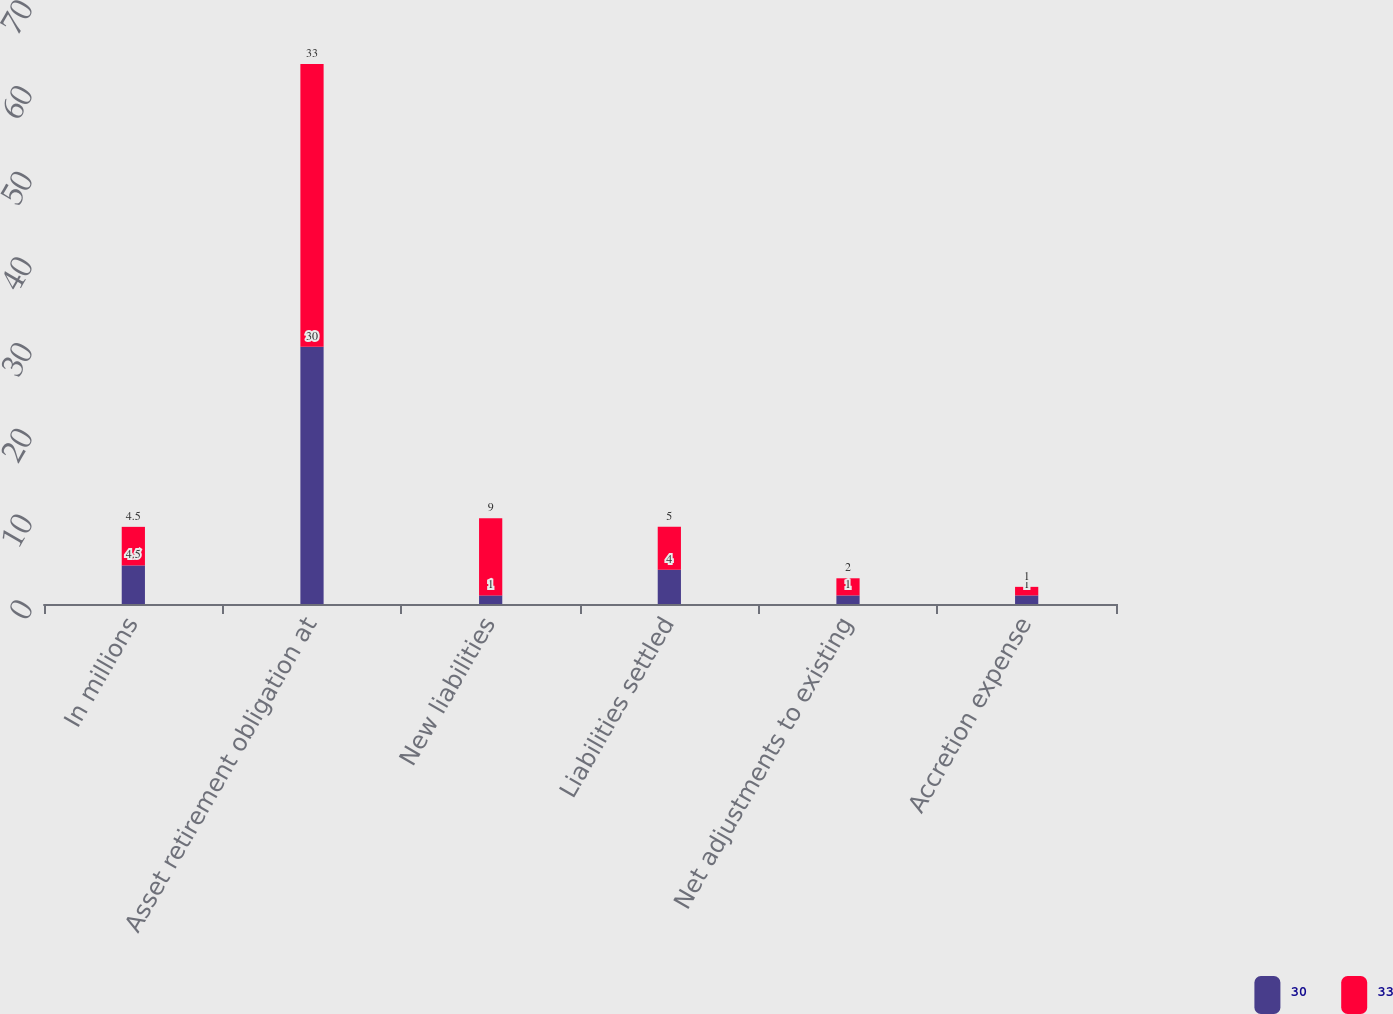Convert chart. <chart><loc_0><loc_0><loc_500><loc_500><stacked_bar_chart><ecel><fcel>In millions<fcel>Asset retirement obligation at<fcel>New liabilities<fcel>Liabilities settled<fcel>Net adjustments to existing<fcel>Accretion expense<nl><fcel>30<fcel>4.5<fcel>30<fcel>1<fcel>4<fcel>1<fcel>1<nl><fcel>33<fcel>4.5<fcel>33<fcel>9<fcel>5<fcel>2<fcel>1<nl></chart> 